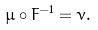Convert formula to latex. <formula><loc_0><loc_0><loc_500><loc_500>\mu \circ F ^ { - 1 } = \nu .</formula> 